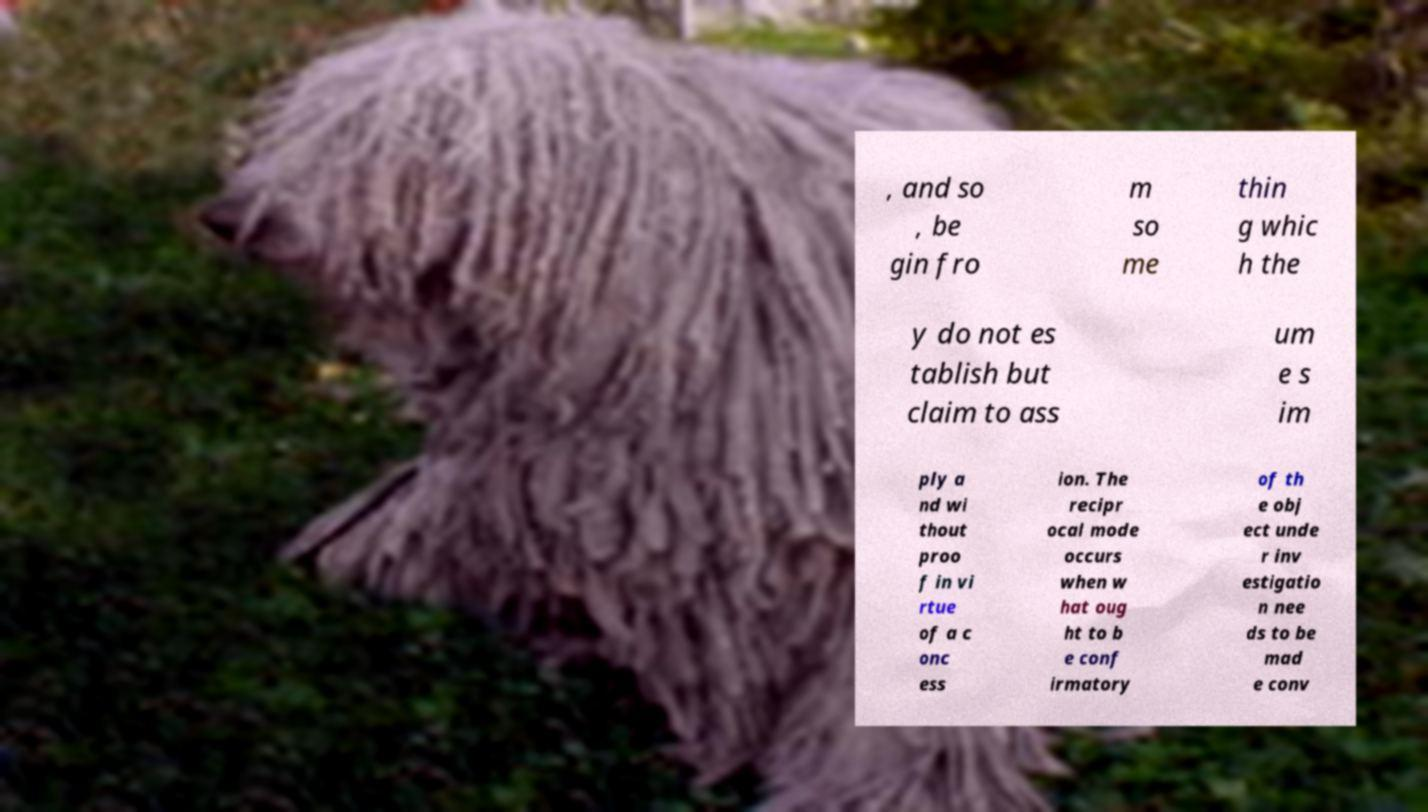There's text embedded in this image that I need extracted. Can you transcribe it verbatim? , and so , be gin fro m so me thin g whic h the y do not es tablish but claim to ass um e s im ply a nd wi thout proo f in vi rtue of a c onc ess ion. The recipr ocal mode occurs when w hat oug ht to b e conf irmatory of th e obj ect unde r inv estigatio n nee ds to be mad e conv 